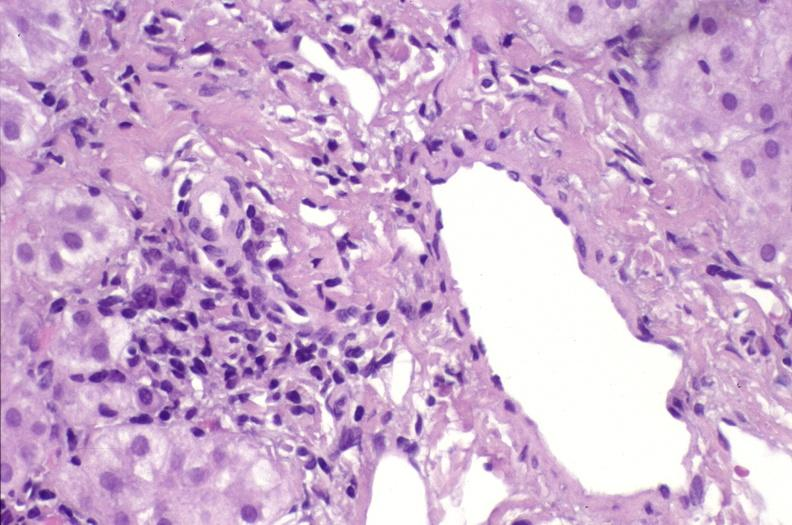s the superior vena cava present?
Answer the question using a single word or phrase. No 